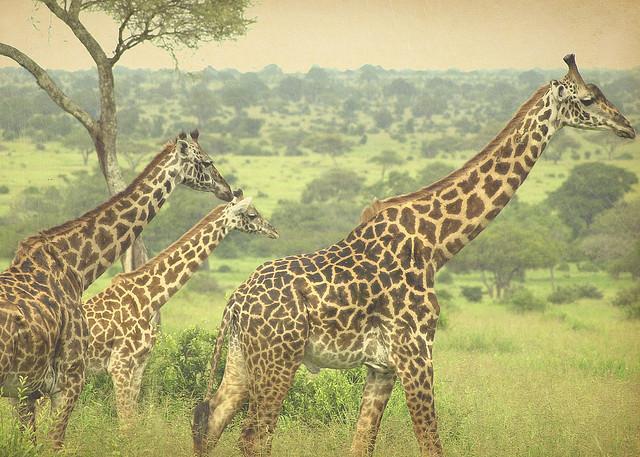How many giraffe are walking across the field?
Give a very brief answer. 3. How many giraffes are visible?
Give a very brief answer. 3. How many clocks can be seen on the building?
Give a very brief answer. 0. 